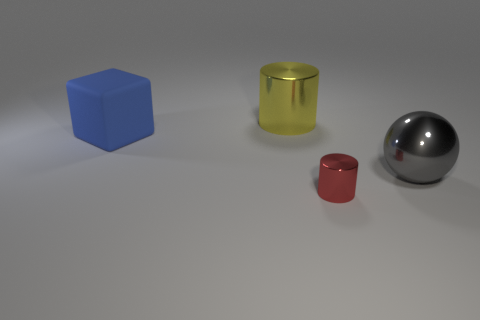Are there any other things that are the same material as the cube?
Provide a succinct answer. No. The cylinder behind the cylinder in front of the shiny object that is on the right side of the tiny red metal cylinder is what color?
Give a very brief answer. Yellow. What is the color of the big cylinder that is the same material as the small red cylinder?
Provide a short and direct response. Yellow. Are there any other things that are the same size as the red object?
Give a very brief answer. No. What number of things are either big things that are on the left side of the red shiny cylinder or big objects in front of the large shiny cylinder?
Your answer should be very brief. 3. Do the cylinder behind the blue matte cube and the shiny object to the right of the tiny object have the same size?
Offer a very short reply. Yes. What color is the other metal object that is the same shape as the big yellow object?
Keep it short and to the point. Red. Is there anything else that has the same shape as the rubber thing?
Provide a short and direct response. No. Is the number of objects to the left of the big yellow metallic thing greater than the number of gray metallic balls that are left of the block?
Offer a very short reply. Yes. What is the size of the metallic cylinder that is to the right of the cylinder behind the metal cylinder that is in front of the large metal cylinder?
Provide a succinct answer. Small. 